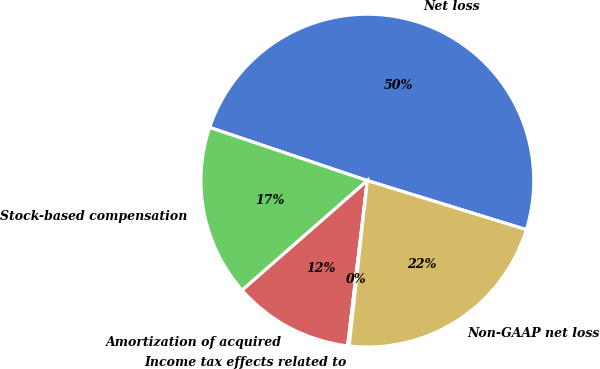<chart> <loc_0><loc_0><loc_500><loc_500><pie_chart><fcel>Net loss<fcel>Stock-based compensation<fcel>Amortization of acquired<fcel>Income tax effects related to<fcel>Non-GAAP net loss<nl><fcel>49.59%<fcel>16.62%<fcel>11.67%<fcel>0.14%<fcel>21.98%<nl></chart> 